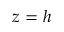Convert formula to latex. <formula><loc_0><loc_0><loc_500><loc_500>z = h</formula> 